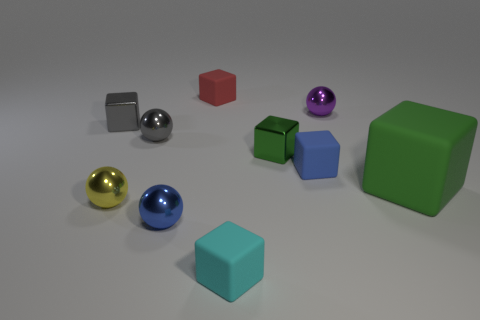What is the shape of the small thing that is the same color as the big rubber object?
Provide a succinct answer. Cube. How many red blocks have the same material as the blue cube?
Provide a short and direct response. 1. There is a red block; what number of tiny objects are right of it?
Your answer should be compact. 4. What is the size of the yellow sphere?
Make the answer very short. Small. There is another metal block that is the same size as the gray cube; what is its color?
Keep it short and to the point. Green. Is there a small rubber thing that has the same color as the big cube?
Ensure brevity in your answer.  No. What is the purple sphere made of?
Keep it short and to the point. Metal. What number of small purple rubber blocks are there?
Provide a succinct answer. 0. There is a small cube on the left side of the red block; does it have the same color as the tiny matte thing behind the green metal cube?
Offer a terse response. No. What is the size of the metal thing that is the same color as the big block?
Ensure brevity in your answer.  Small. 